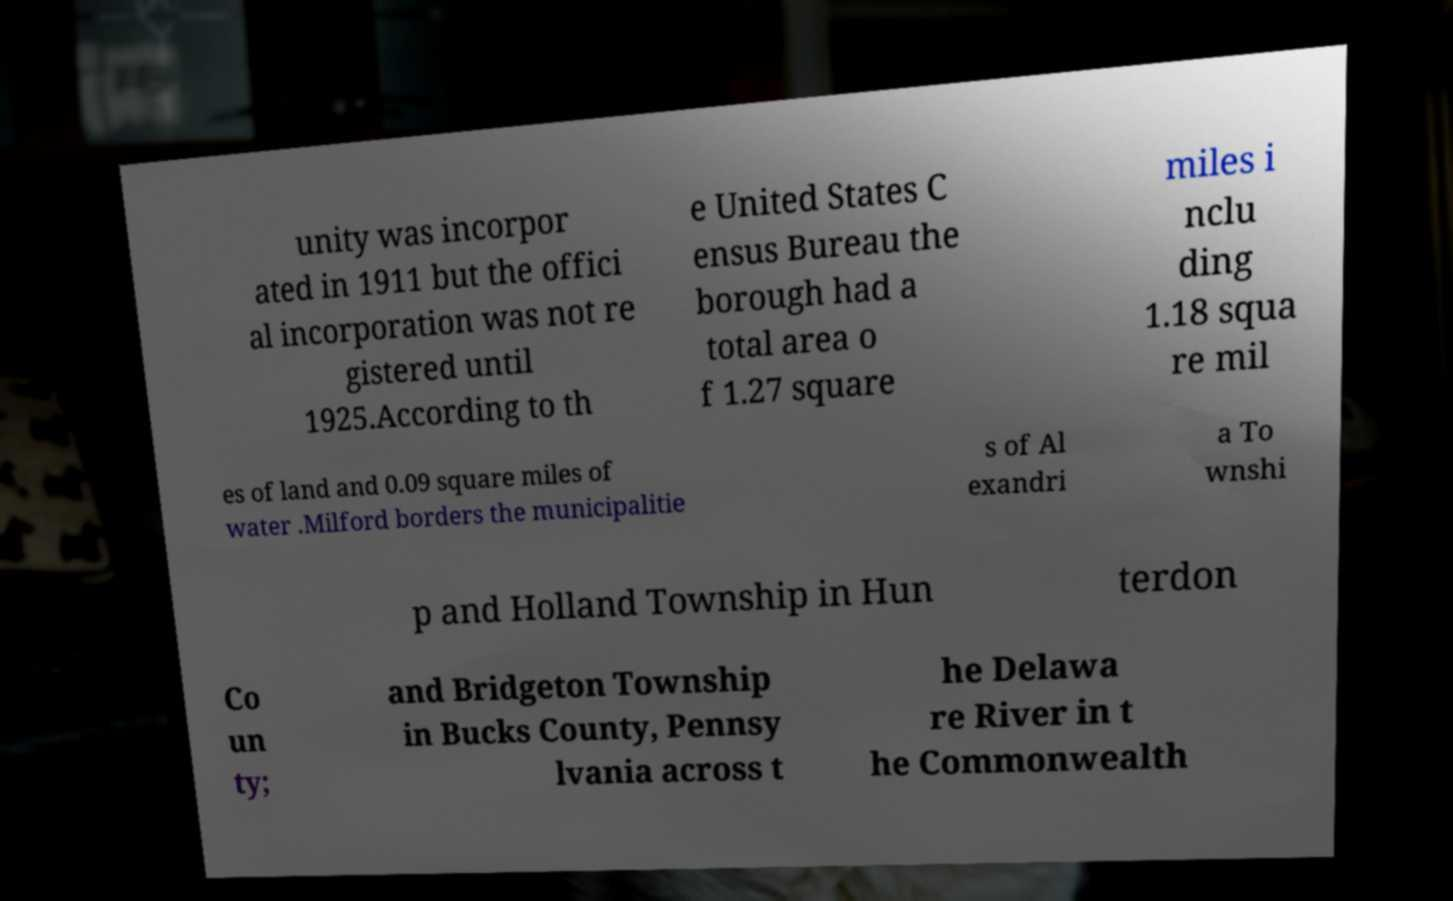Please identify and transcribe the text found in this image. unity was incorpor ated in 1911 but the offici al incorporation was not re gistered until 1925.According to th e United States C ensus Bureau the borough had a total area o f 1.27 square miles i nclu ding 1.18 squa re mil es of land and 0.09 square miles of water .Milford borders the municipalitie s of Al exandri a To wnshi p and Holland Township in Hun terdon Co un ty; and Bridgeton Township in Bucks County, Pennsy lvania across t he Delawa re River in t he Commonwealth 